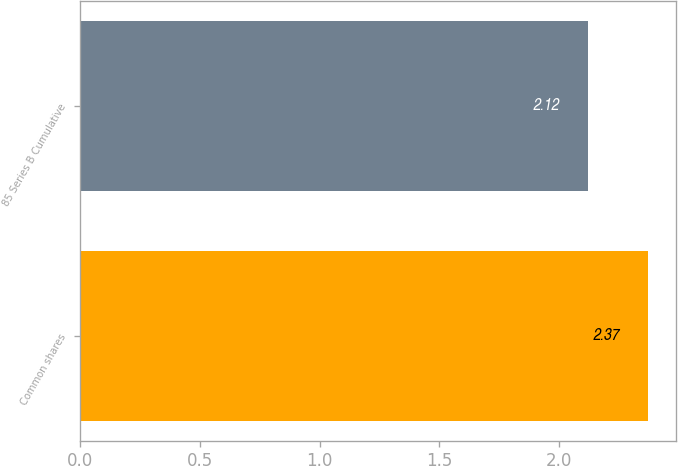<chart> <loc_0><loc_0><loc_500><loc_500><bar_chart><fcel>Common shares<fcel>85 Series B Cumulative<nl><fcel>2.37<fcel>2.12<nl></chart> 